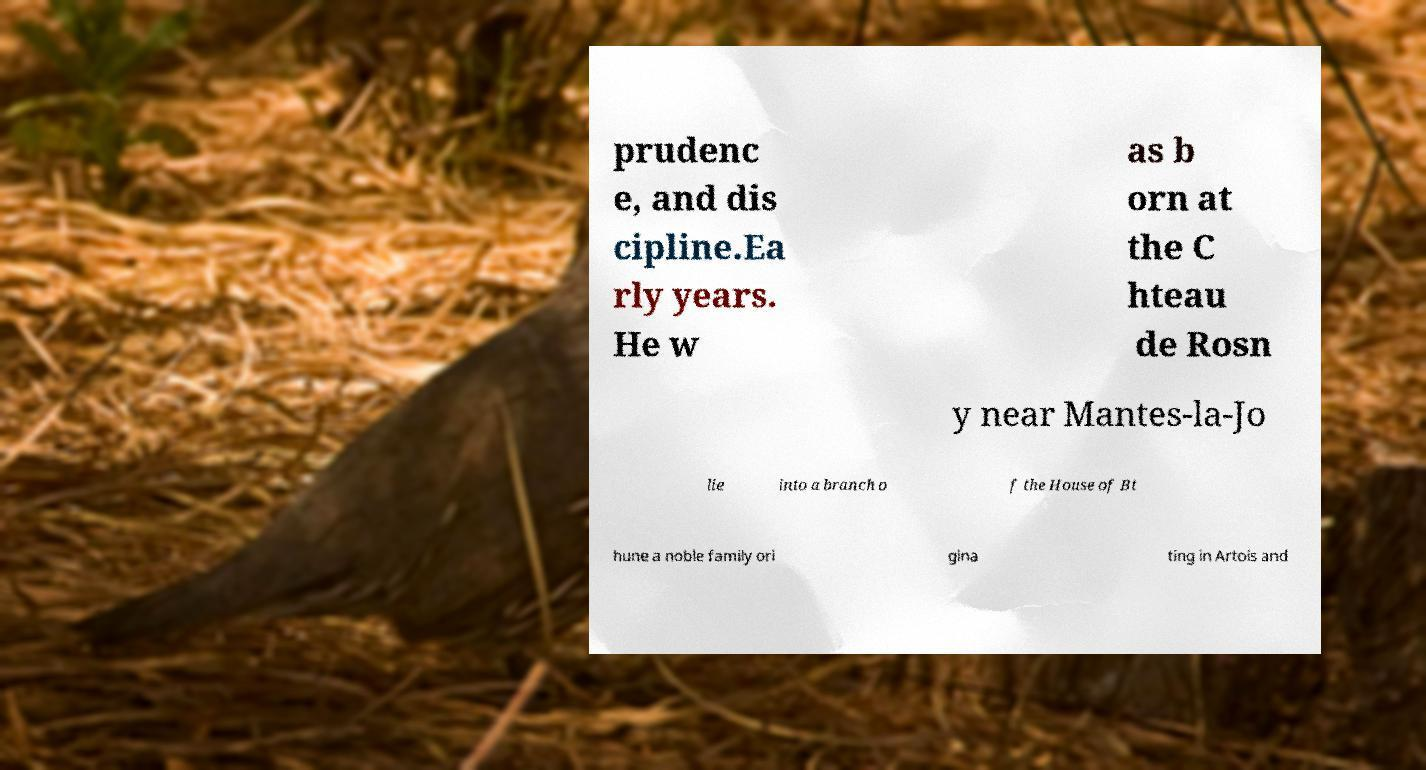For documentation purposes, I need the text within this image transcribed. Could you provide that? prudenc e, and dis cipline.Ea rly years. He w as b orn at the C hteau de Rosn y near Mantes-la-Jo lie into a branch o f the House of Bt hune a noble family ori gina ting in Artois and 